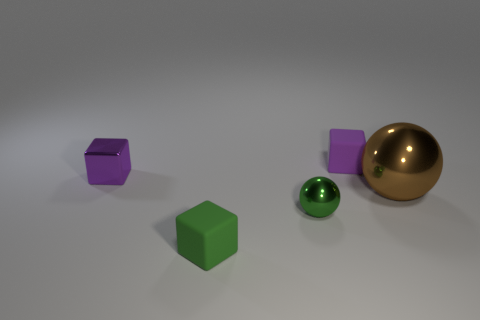Subtract all purple blocks. How many were subtracted if there are1purple blocks left? 1 Subtract all purple blocks. How many blocks are left? 1 Subtract all green cubes. How many cubes are left? 2 Add 2 metallic cubes. How many metallic cubes exist? 3 Add 5 tiny things. How many objects exist? 10 Subtract 0 brown cylinders. How many objects are left? 5 Subtract all cubes. How many objects are left? 2 Subtract 2 cubes. How many cubes are left? 1 Subtract all blue balls. Subtract all yellow blocks. How many balls are left? 2 Subtract all green cubes. How many green spheres are left? 1 